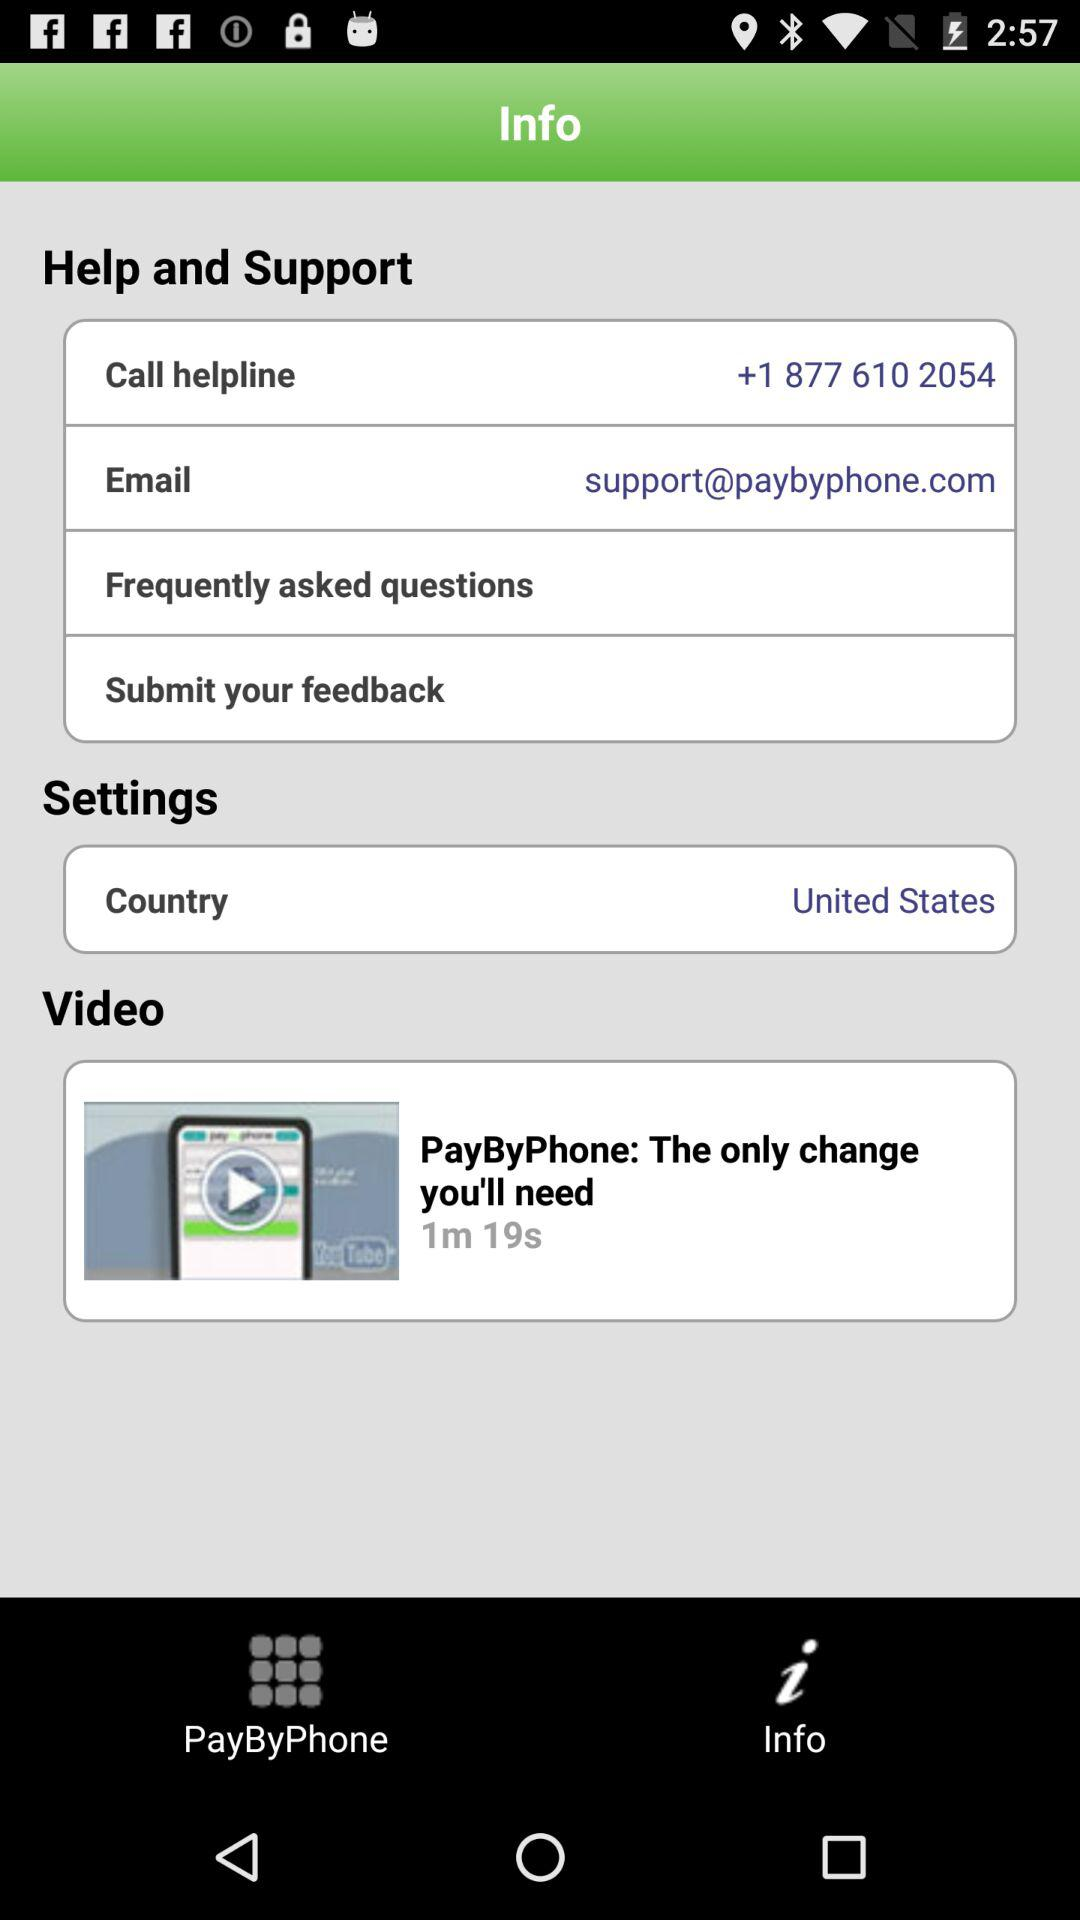What is the duration of the given video? The duration of the given video is 1 minute and 19 seconds. 